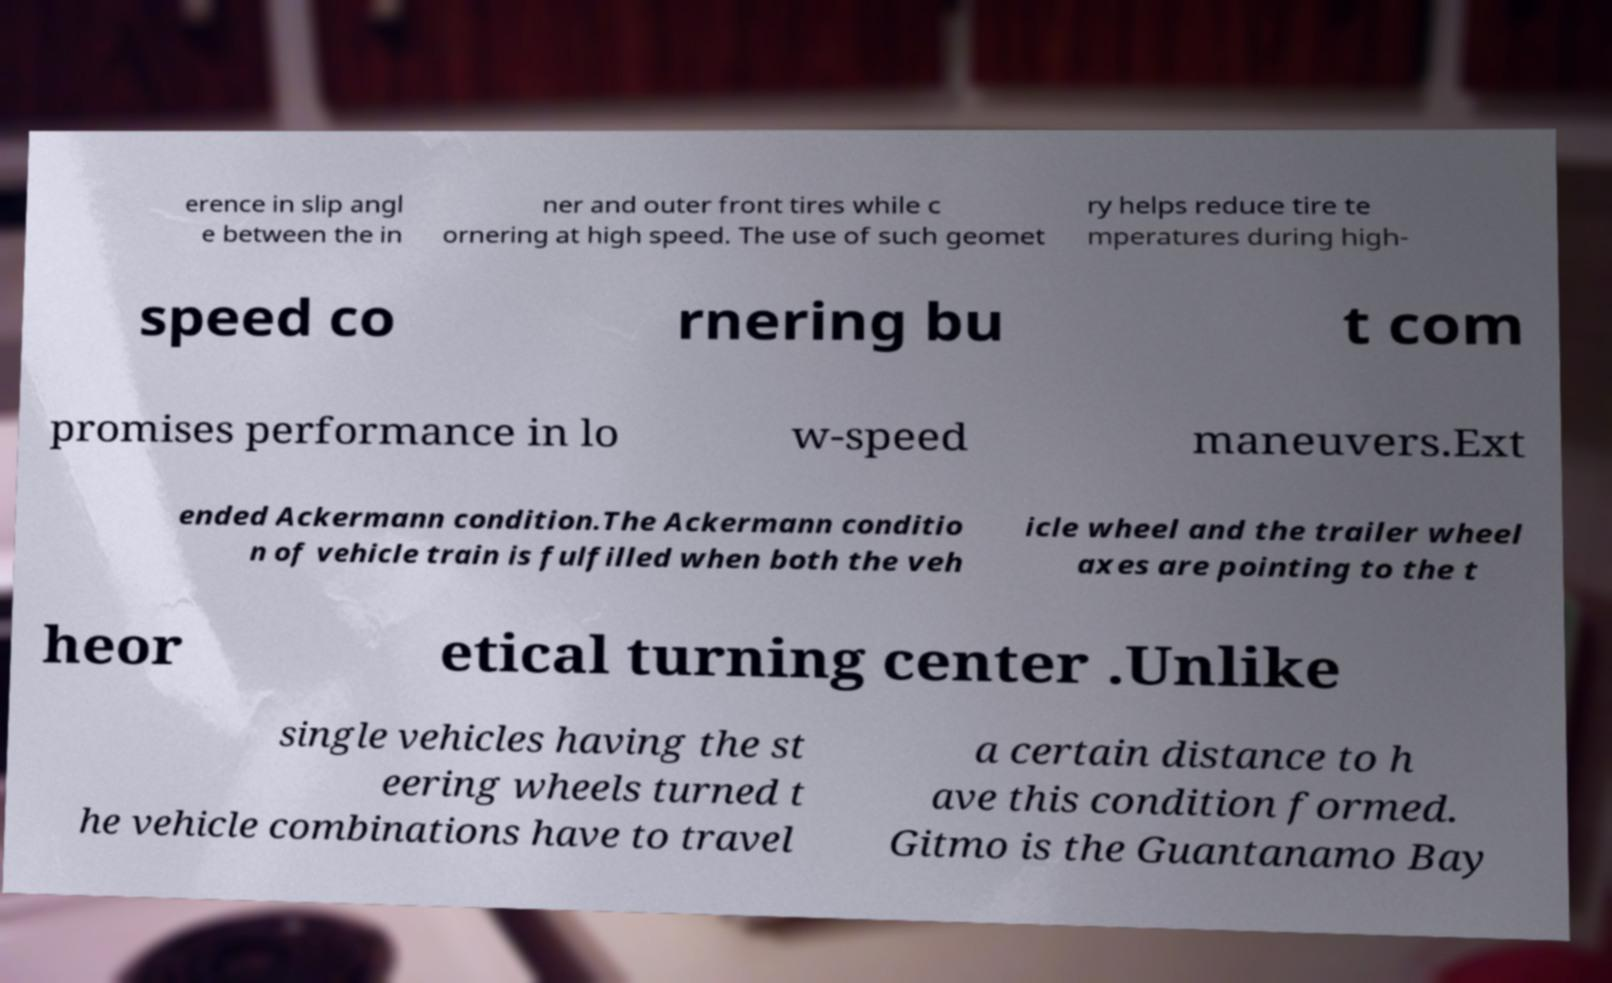For documentation purposes, I need the text within this image transcribed. Could you provide that? erence in slip angl e between the in ner and outer front tires while c ornering at high speed. The use of such geomet ry helps reduce tire te mperatures during high- speed co rnering bu t com promises performance in lo w-speed maneuvers.Ext ended Ackermann condition.The Ackermann conditio n of vehicle train is fulfilled when both the veh icle wheel and the trailer wheel axes are pointing to the t heor etical turning center .Unlike single vehicles having the st eering wheels turned t he vehicle combinations have to travel a certain distance to h ave this condition formed. Gitmo is the Guantanamo Bay 